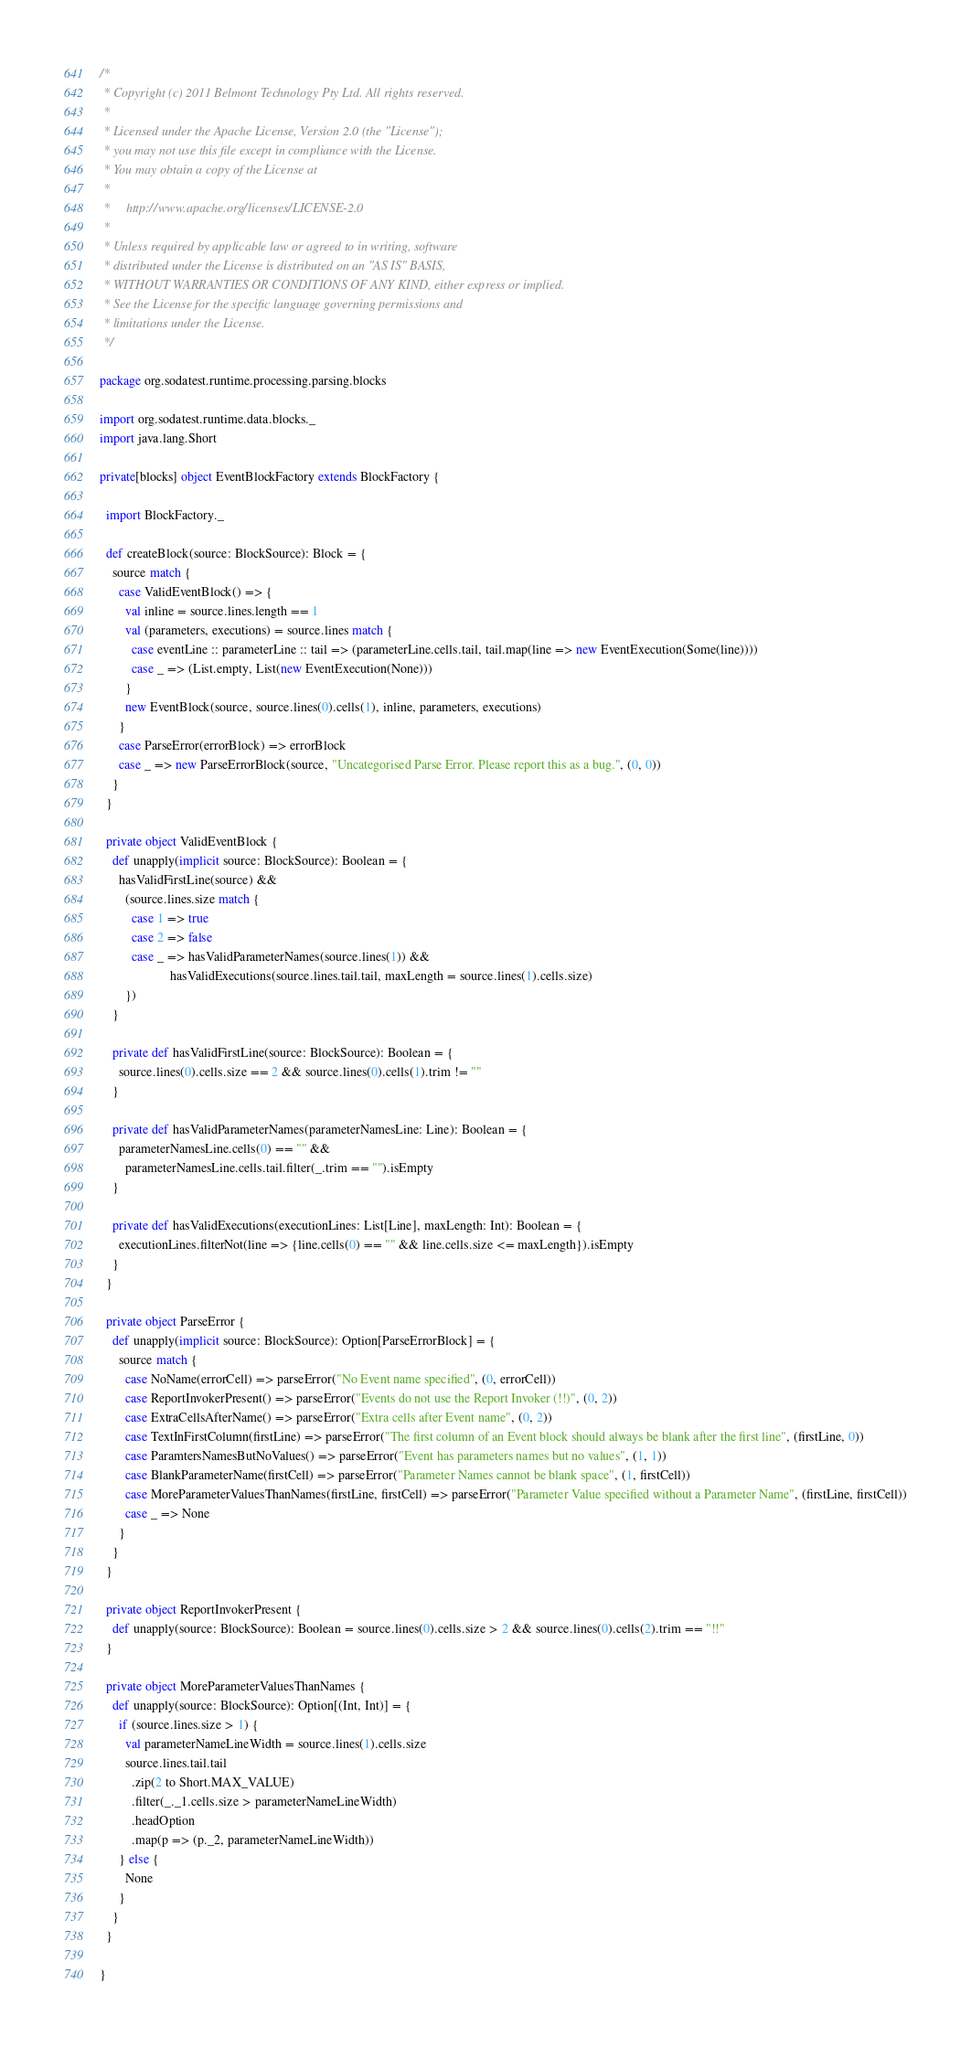<code> <loc_0><loc_0><loc_500><loc_500><_Scala_>/*
 * Copyright (c) 2011 Belmont Technology Pty Ltd. All rights reserved.
 *
 * Licensed under the Apache License, Version 2.0 (the "License");
 * you may not use this file except in compliance with the License.
 * You may obtain a copy of the License at
 *
 *     http://www.apache.org/licenses/LICENSE-2.0
 *
 * Unless required by applicable law or agreed to in writing, software
 * distributed under the License is distributed on an "AS IS" BASIS,
 * WITHOUT WARRANTIES OR CONDITIONS OF ANY KIND, either express or implied.
 * See the License for the specific language governing permissions and
 * limitations under the License.
 */

package org.sodatest.runtime.processing.parsing.blocks

import org.sodatest.runtime.data.blocks._
import java.lang.Short

private[blocks] object EventBlockFactory extends BlockFactory {

  import BlockFactory._

  def createBlock(source: BlockSource): Block = {
    source match {
      case ValidEventBlock() => {
        val inline = source.lines.length == 1
        val (parameters, executions) = source.lines match {
          case eventLine :: parameterLine :: tail => (parameterLine.cells.tail, tail.map(line => new EventExecution(Some(line))))
          case _ => (List.empty, List(new EventExecution(None)))
        }
        new EventBlock(source, source.lines(0).cells(1), inline, parameters, executions)
      }
      case ParseError(errorBlock) => errorBlock
      case _ => new ParseErrorBlock(source, "Uncategorised Parse Error. Please report this as a bug.", (0, 0))
    }
  }

  private object ValidEventBlock {
    def unapply(implicit source: BlockSource): Boolean = {
      hasValidFirstLine(source) &&
        (source.lines.size match {
          case 1 => true
          case 2 => false
          case _ => hasValidParameterNames(source.lines(1)) &&
                      hasValidExecutions(source.lines.tail.tail, maxLength = source.lines(1).cells.size)
        })
    }

    private def hasValidFirstLine(source: BlockSource): Boolean = {
      source.lines(0).cells.size == 2 && source.lines(0).cells(1).trim != ""
    }

    private def hasValidParameterNames(parameterNamesLine: Line): Boolean = {
      parameterNamesLine.cells(0) == "" &&
        parameterNamesLine.cells.tail.filter(_.trim == "").isEmpty
    }

    private def hasValidExecutions(executionLines: List[Line], maxLength: Int): Boolean = {
      executionLines.filterNot(line => {line.cells(0) == "" && line.cells.size <= maxLength}).isEmpty
    }
  }

  private object ParseError {
    def unapply(implicit source: BlockSource): Option[ParseErrorBlock] = {
      source match {
        case NoName(errorCell) => parseError("No Event name specified", (0, errorCell))
        case ReportInvokerPresent() => parseError("Events do not use the Report Invoker (!!)", (0, 2))
        case ExtraCellsAfterName() => parseError("Extra cells after Event name", (0, 2))
        case TextInFirstColumn(firstLine) => parseError("The first column of an Event block should always be blank after the first line", (firstLine, 0))
        case ParamtersNamesButNoValues() => parseError("Event has parameters names but no values", (1, 1))
        case BlankParameterName(firstCell) => parseError("Parameter Names cannot be blank space", (1, firstCell))
        case MoreParameterValuesThanNames(firstLine, firstCell) => parseError("Parameter Value specified without a Parameter Name", (firstLine, firstCell))
        case _ => None
      }
    }
  }

  private object ReportInvokerPresent {
    def unapply(source: BlockSource): Boolean = source.lines(0).cells.size > 2 && source.lines(0).cells(2).trim == "!!"
  }

  private object MoreParameterValuesThanNames {
    def unapply(source: BlockSource): Option[(Int, Int)] = {
      if (source.lines.size > 1) {
        val parameterNameLineWidth = source.lines(1).cells.size
        source.lines.tail.tail
          .zip(2 to Short.MAX_VALUE)
          .filter(_._1.cells.size > parameterNameLineWidth)
          .headOption
          .map(p => (p._2, parameterNameLineWidth))
      } else {
        None
      }
    }
  }

}

</code> 